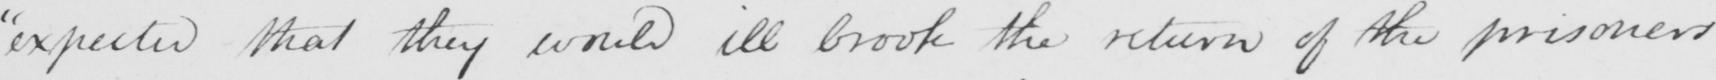Can you read and transcribe this handwriting? " expected that they would ill brook the return of the prisoners 